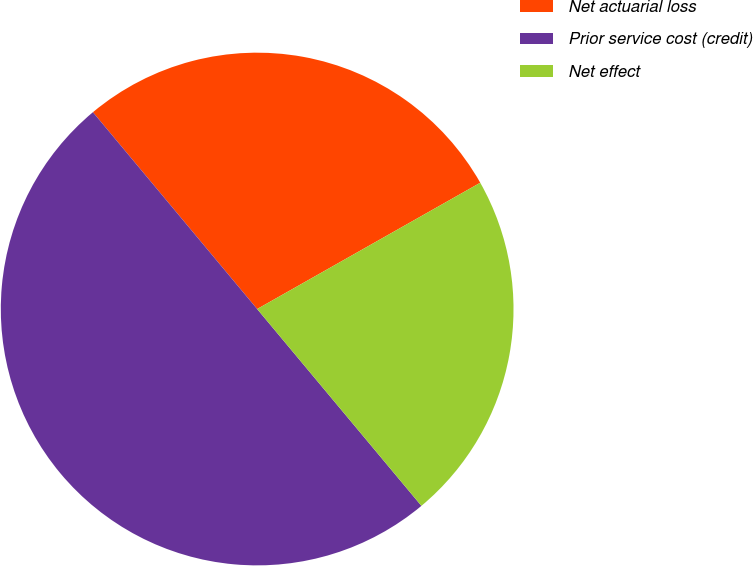Convert chart to OTSL. <chart><loc_0><loc_0><loc_500><loc_500><pie_chart><fcel>Net actuarial loss<fcel>Prior service cost (credit)<fcel>Net effect<nl><fcel>27.87%<fcel>50.0%<fcel>22.13%<nl></chart> 